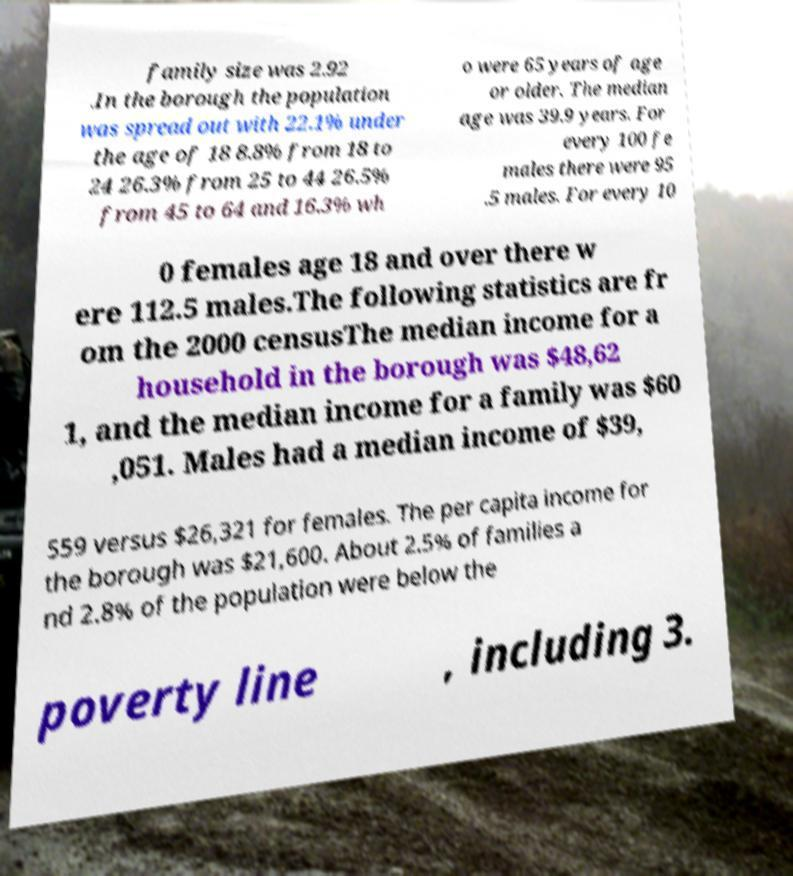Can you read and provide the text displayed in the image?This photo seems to have some interesting text. Can you extract and type it out for me? family size was 2.92 .In the borough the population was spread out with 22.1% under the age of 18 8.8% from 18 to 24 26.3% from 25 to 44 26.5% from 45 to 64 and 16.3% wh o were 65 years of age or older. The median age was 39.9 years. For every 100 fe males there were 95 .5 males. For every 10 0 females age 18 and over there w ere 112.5 males.The following statistics are fr om the 2000 censusThe median income for a household in the borough was $48,62 1, and the median income for a family was $60 ,051. Males had a median income of $39, 559 versus $26,321 for females. The per capita income for the borough was $21,600. About 2.5% of families a nd 2.8% of the population were below the poverty line , including 3. 